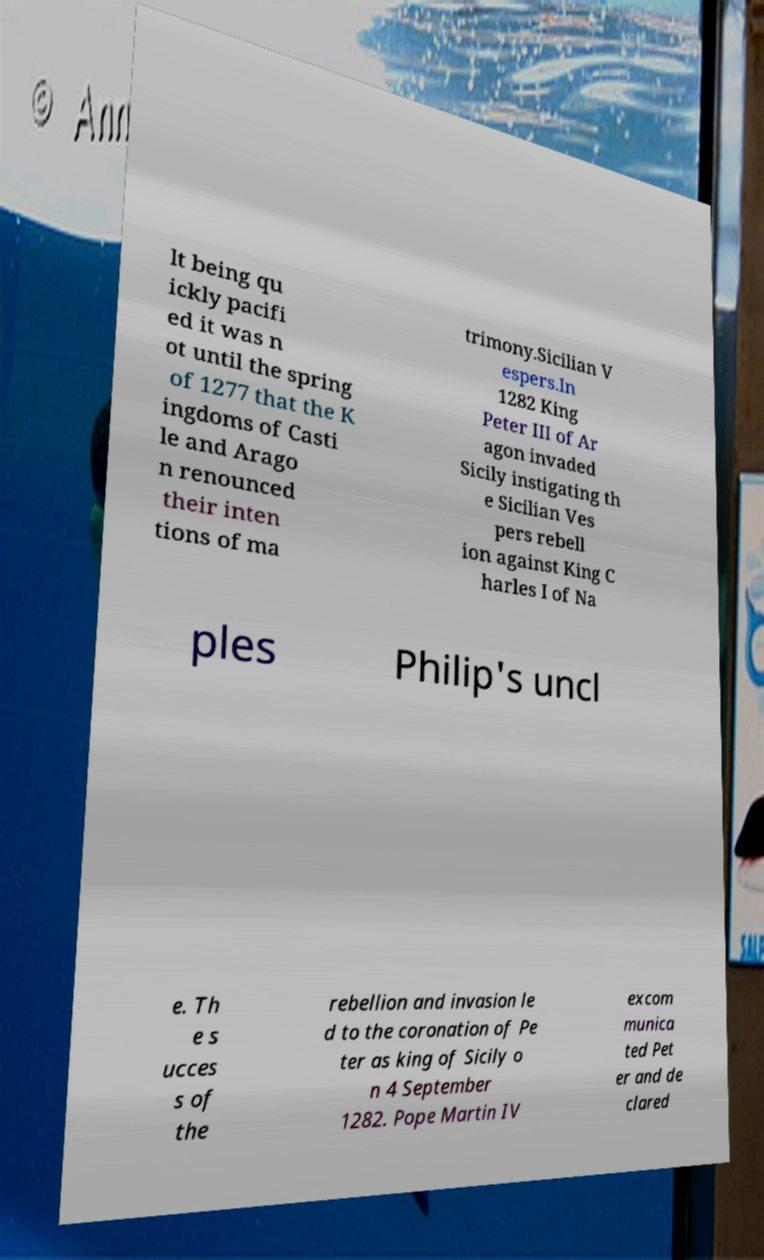Can you accurately transcribe the text from the provided image for me? lt being qu ickly pacifi ed it was n ot until the spring of 1277 that the K ingdoms of Casti le and Arago n renounced their inten tions of ma trimony.Sicilian V espers.In 1282 King Peter III of Ar agon invaded Sicily instigating th e Sicilian Ves pers rebell ion against King C harles I of Na ples Philip's uncl e. Th e s ucces s of the rebellion and invasion le d to the coronation of Pe ter as king of Sicily o n 4 September 1282. Pope Martin IV excom munica ted Pet er and de clared 